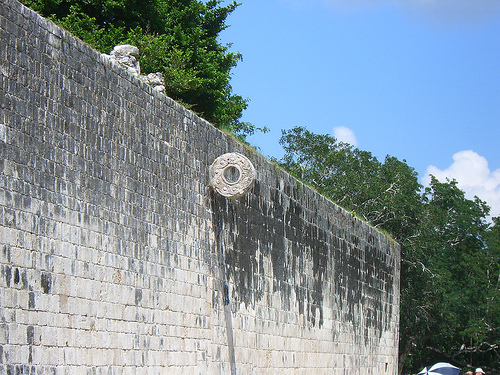<image>
Is there a building on the tree? No. The building is not positioned on the tree. They may be near each other, but the building is not supported by or resting on top of the tree. 